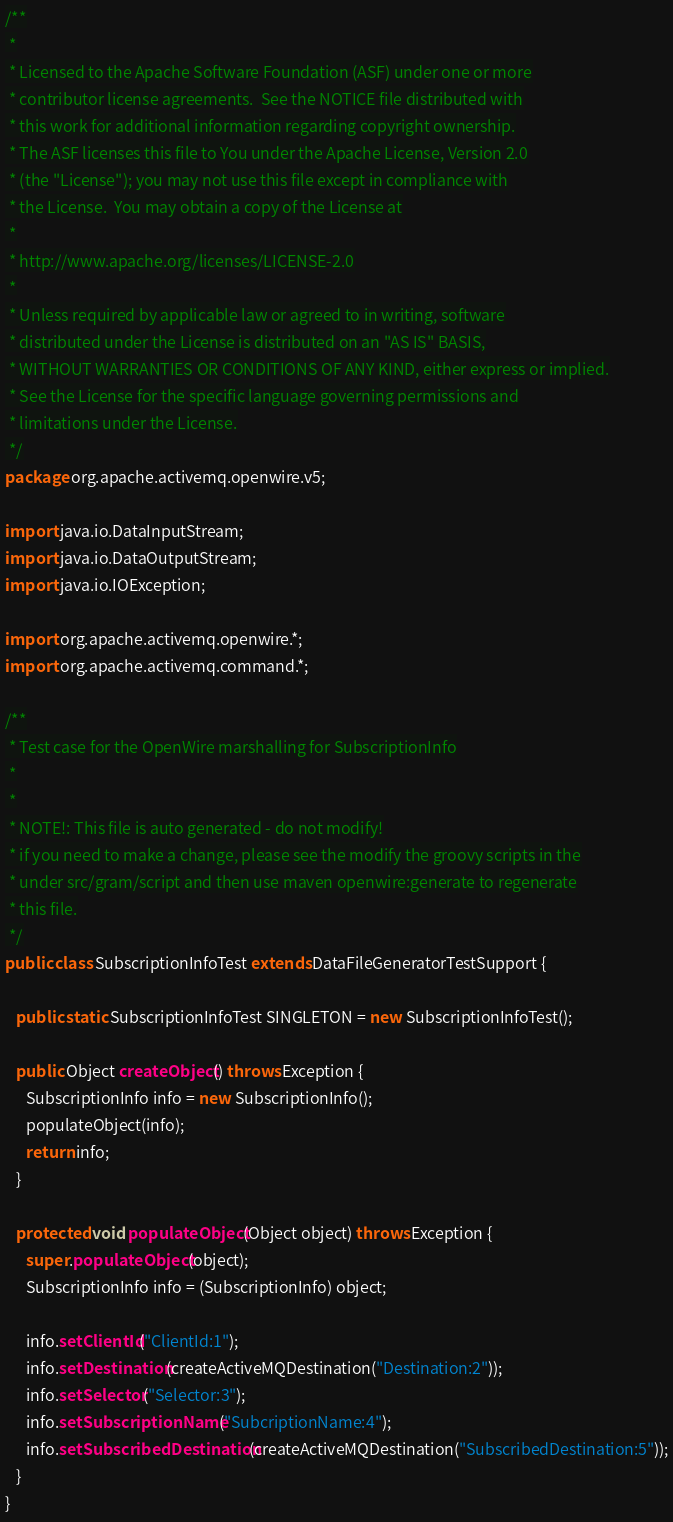<code> <loc_0><loc_0><loc_500><loc_500><_Java_>/**
 *
 * Licensed to the Apache Software Foundation (ASF) under one or more
 * contributor license agreements.  See the NOTICE file distributed with
 * this work for additional information regarding copyright ownership.
 * The ASF licenses this file to You under the Apache License, Version 2.0
 * (the "License"); you may not use this file except in compliance with
 * the License.  You may obtain a copy of the License at
 *
 * http://www.apache.org/licenses/LICENSE-2.0
 *
 * Unless required by applicable law or agreed to in writing, software
 * distributed under the License is distributed on an "AS IS" BASIS,
 * WITHOUT WARRANTIES OR CONDITIONS OF ANY KIND, either express or implied.
 * See the License for the specific language governing permissions and
 * limitations under the License.
 */
package org.apache.activemq.openwire.v5;

import java.io.DataInputStream;
import java.io.DataOutputStream;
import java.io.IOException;

import org.apache.activemq.openwire.*;
import org.apache.activemq.command.*;

/**
 * Test case for the OpenWire marshalling for SubscriptionInfo
 *
 *
 * NOTE!: This file is auto generated - do not modify!
 * if you need to make a change, please see the modify the groovy scripts in the
 * under src/gram/script and then use maven openwire:generate to regenerate
 * this file.
 */
public class SubscriptionInfoTest extends DataFileGeneratorTestSupport {

   public static SubscriptionInfoTest SINGLETON = new SubscriptionInfoTest();

   public Object createObject() throws Exception {
      SubscriptionInfo info = new SubscriptionInfo();
      populateObject(info);
      return info;
   }

   protected void populateObject(Object object) throws Exception {
      super.populateObject(object);
      SubscriptionInfo info = (SubscriptionInfo) object;

      info.setClientId("ClientId:1");
      info.setDestination(createActiveMQDestination("Destination:2"));
      info.setSelector("Selector:3");
      info.setSubscriptionName("SubcriptionName:4");
      info.setSubscribedDestination(createActiveMQDestination("SubscribedDestination:5"));
   }
}
</code> 